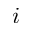<formula> <loc_0><loc_0><loc_500><loc_500>i</formula> 